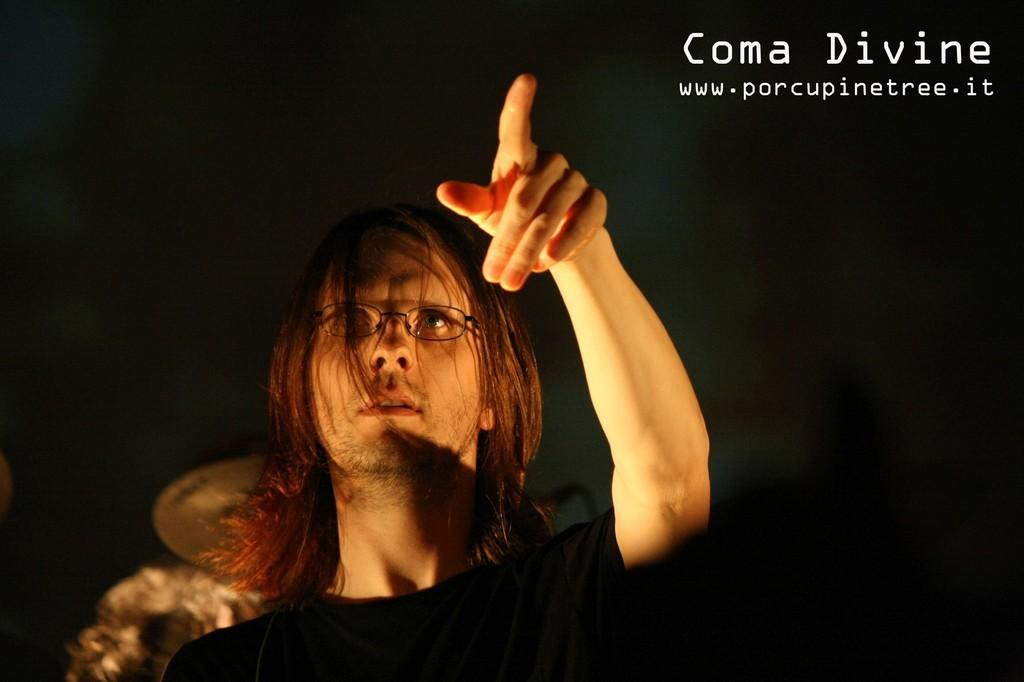Who is present in the image? There is a man in the image. What accessory is the man wearing? The man is wearing spectacles. What can be observed about the background of the image? The background of the image is dark. How many cows are visible in the image? There are no cows present in the image. What page is the man reading from in the image? There is no book or page visible in the image. 